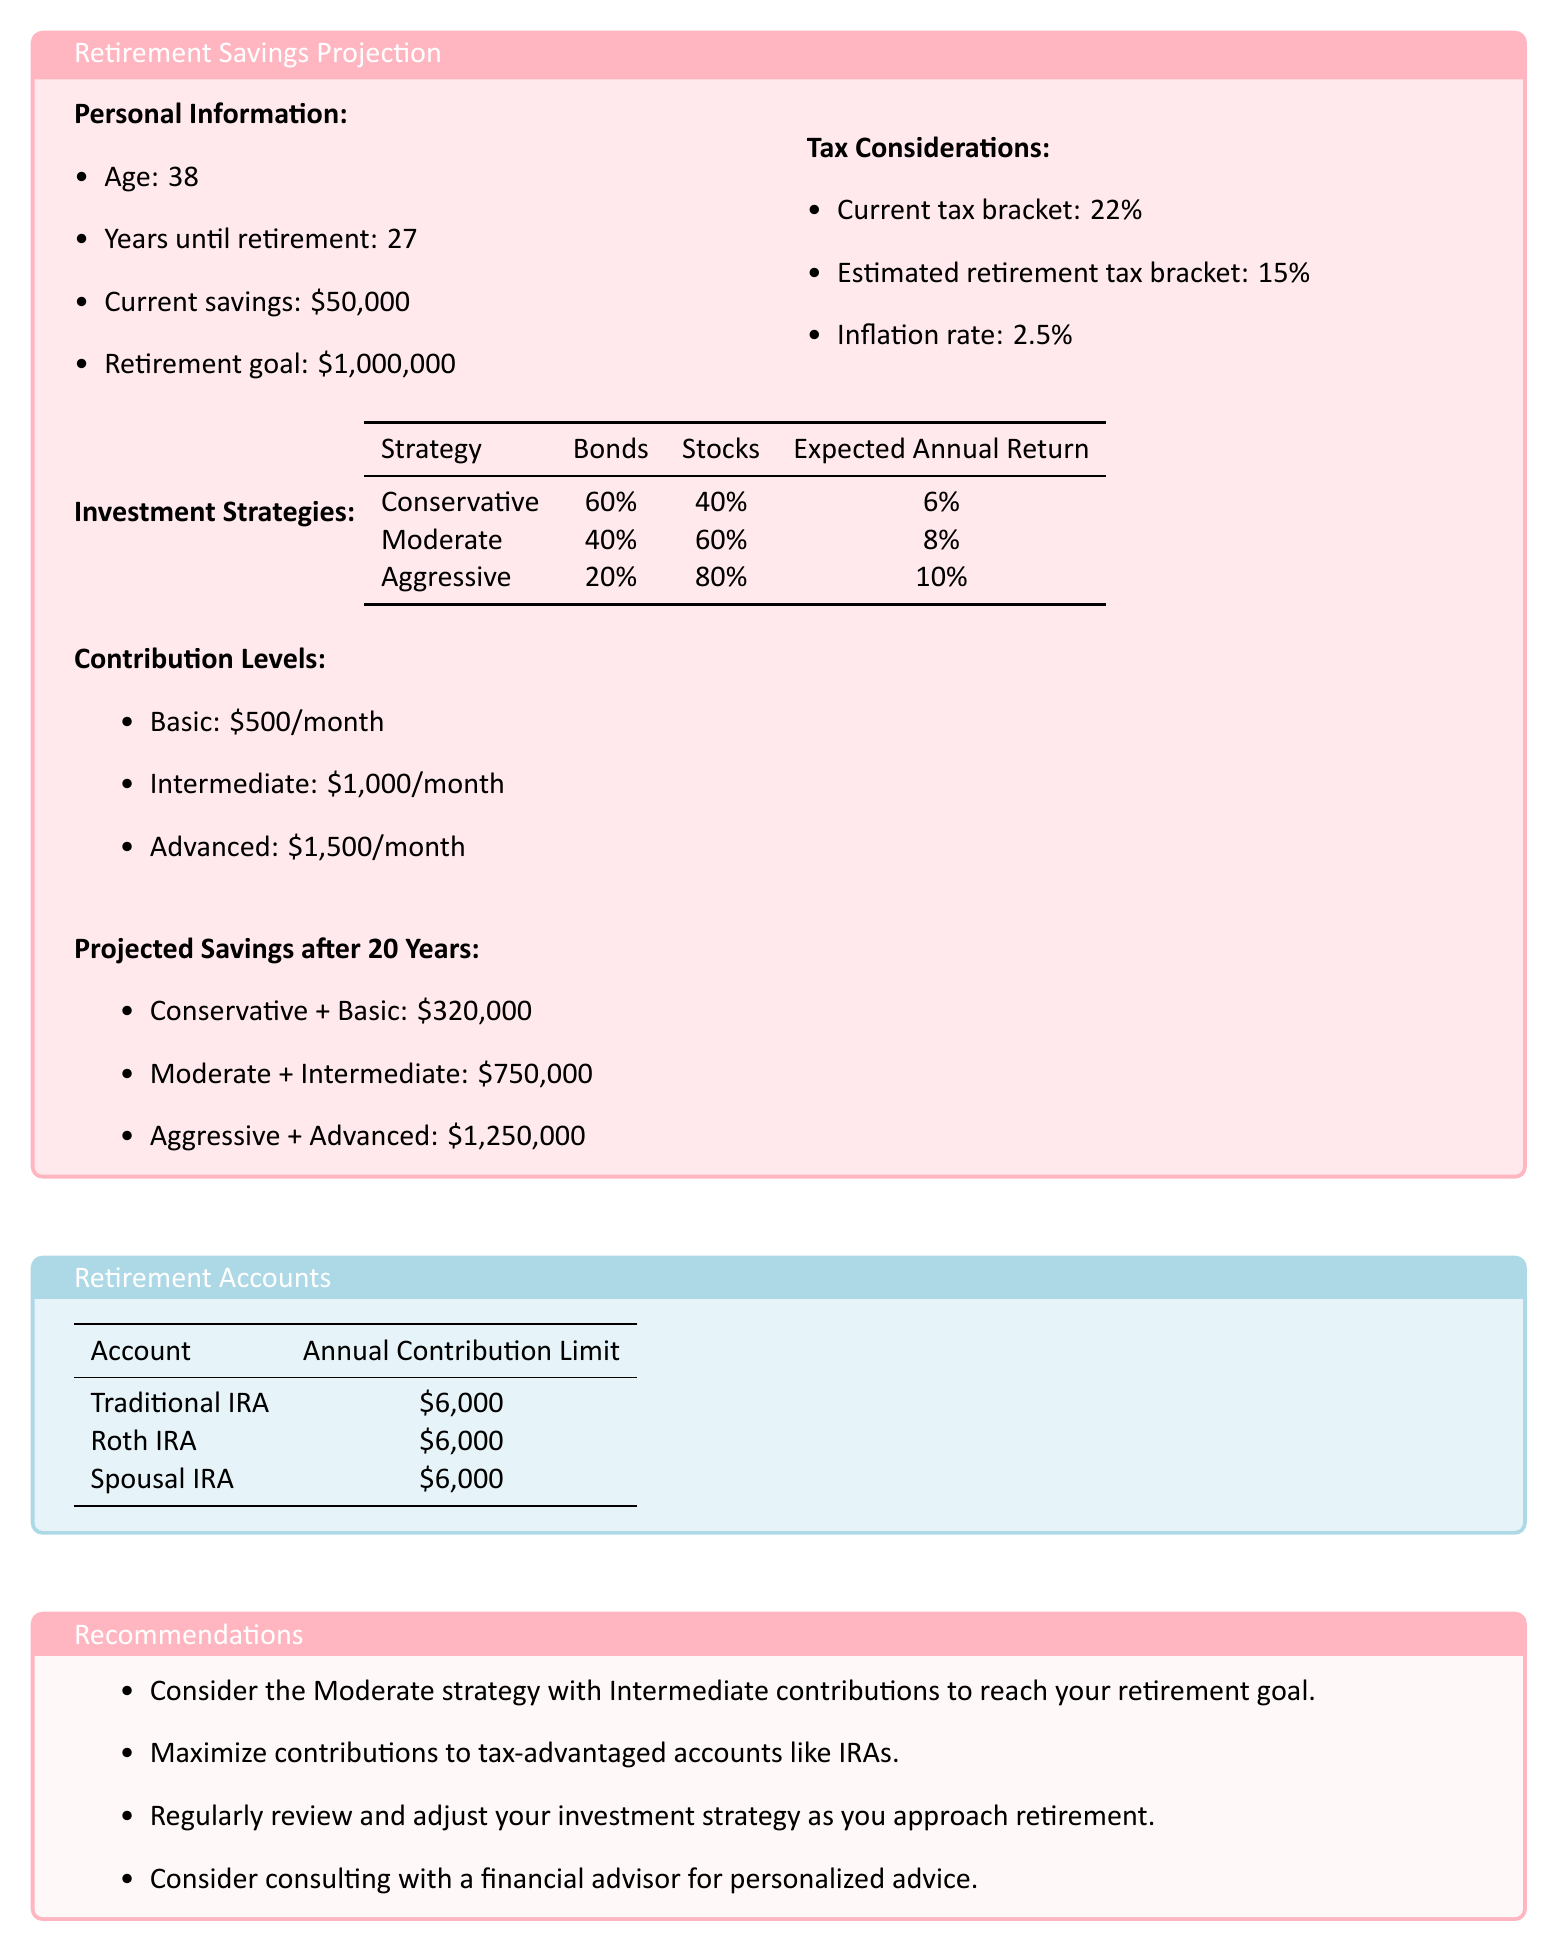What is the current savings amount? The document states that the current savings amount is $50,000.
Answer: $50,000 What is the retirement goal? According to the document, the retirement goal is $1,000,000.
Answer: $1,000,000 What is the expected annual return for the aggressive strategy? The aggressive strategy has an expected annual return of 10%.
Answer: 10% What monthly contribution level corresponds to the conservative strategy? The conservative strategy includes a basic monthly contribution of $500.
Answer: $500 What is the projected savings after 20 years for the moderate strategy with intermediate contributions? The document states that the projected savings is $750,000 for this strategy.
Answer: $750,000 What is the annual contribution limit for a Traditional IRA? The Traditional IRA has an annual contribution limit of $6,000.
Answer: $6,000 Which investment strategy is recommended to reach the retirement goal? The document recommends the moderate strategy with intermediate contributions.
Answer: Moderate strategy with Intermediate contributions How many years are left until retirement? The document indicates there are 27 years until retirement.
Answer: 27 What is the inflation rate considered in the document? The inflation rate mentioned in the document is 2.5%.
Answer: 2.5% 